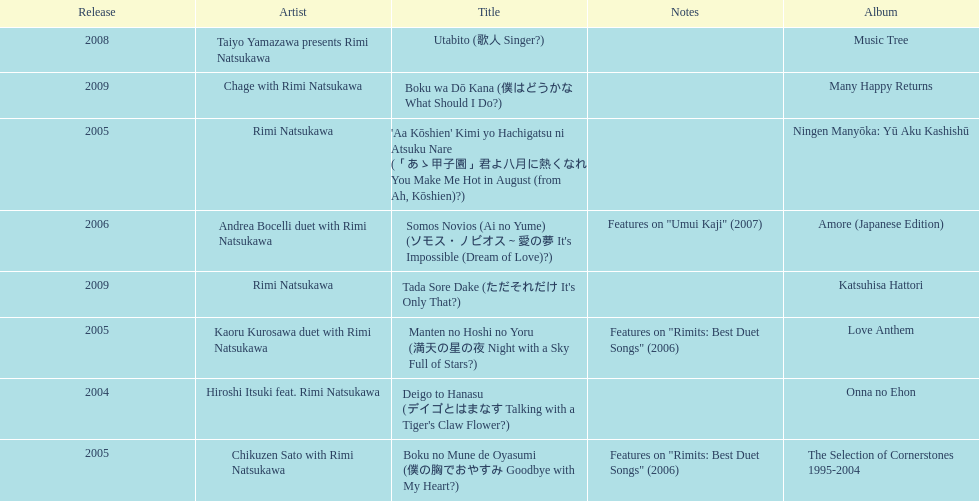Which title has the same notes as night with a sky full of stars? Boku no Mune de Oyasumi (僕の胸でおやすみ Goodbye with My Heart?). 